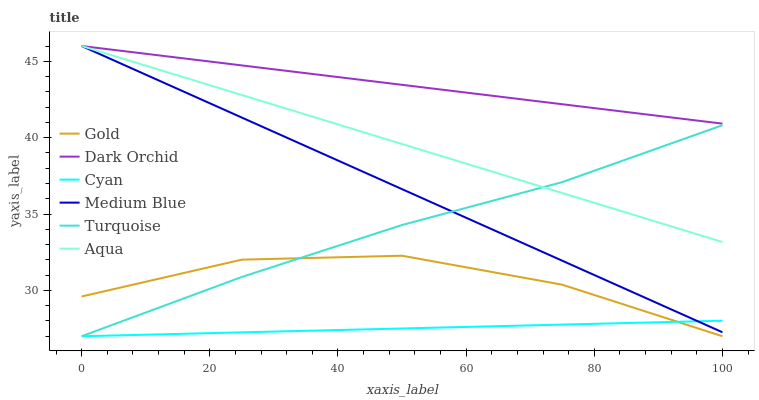Does Gold have the minimum area under the curve?
Answer yes or no. No. Does Gold have the maximum area under the curve?
Answer yes or no. No. Is Medium Blue the smoothest?
Answer yes or no. No. Is Medium Blue the roughest?
Answer yes or no. No. Does Medium Blue have the lowest value?
Answer yes or no. No. Does Gold have the highest value?
Answer yes or no. No. Is Gold less than Dark Orchid?
Answer yes or no. Yes. Is Aqua greater than Gold?
Answer yes or no. Yes. Does Gold intersect Dark Orchid?
Answer yes or no. No. 